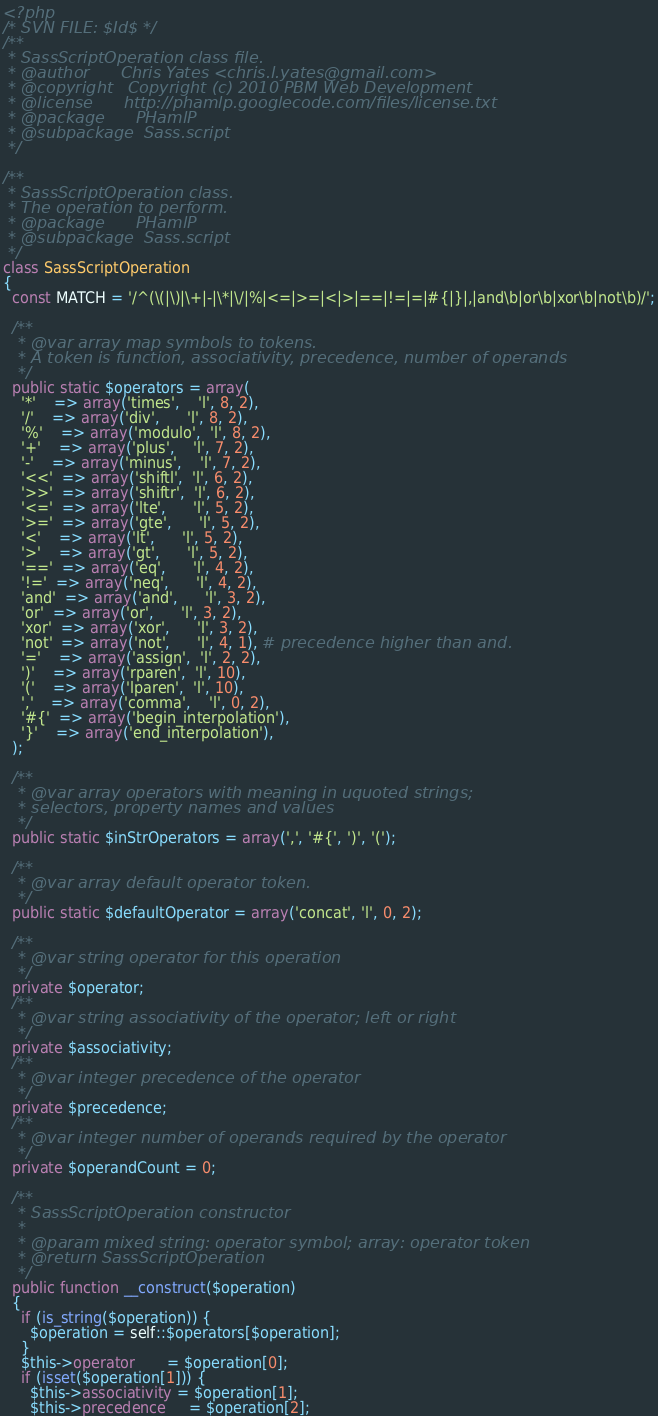Convert code to text. <code><loc_0><loc_0><loc_500><loc_500><_PHP_><?php
/* SVN FILE: $Id$ */
/**
 * SassScriptOperation class file.
 * @author      Chris Yates <chris.l.yates@gmail.com>
 * @copyright   Copyright (c) 2010 PBM Web Development
 * @license      http://phamlp.googlecode.com/files/license.txt
 * @package      PHamlP
 * @subpackage  Sass.script
 */

/**
 * SassScriptOperation class.
 * The operation to perform.
 * @package      PHamlP
 * @subpackage  Sass.script
 */
class SassScriptOperation
{
  const MATCH = '/^(\(|\)|\+|-|\*|\/|%|<=|>=|<|>|==|!=|=|#{|}|,|and\b|or\b|xor\b|not\b)/';

  /**
   * @var array map symbols to tokens.
   * A token is function, associativity, precedence, number of operands
   */
  public static $operators = array(
    '*'    => array('times',    'l', 8, 2),
    '/'    => array('div',      'l', 8, 2),
    '%'    => array('modulo',  'l', 8, 2),
    '+'    => array('plus',    'l', 7, 2),
    '-'    => array('minus',    'l', 7, 2),
    '<<'  => array('shiftl',  'l', 6, 2),
    '>>'  => array('shiftr',  'l', 6, 2),
    '<='  => array('lte',      'l', 5, 2),
    '>='  => array('gte',      'l', 5, 2),
    '<'    => array('lt',      'l', 5, 2),
    '>'    => array('gt',      'l', 5, 2),
    '=='  => array('eq',      'l', 4, 2),
    '!='  => array('neq',      'l', 4, 2),
    'and'  => array('and',      'l', 3, 2),
    'or'  => array('or',      'l', 3, 2),
    'xor'  => array('xor',      'l', 3, 2),
    'not'  => array('not',      'l', 4, 1), # precedence higher than and.
    '='    => array('assign',  'l', 2, 2),
    ')'    => array('rparen',  'l', 10),
    '('    => array('lparen',  'l', 10),
    ','    => array('comma',    'l', 0, 2),
    '#{'  => array('begin_interpolation'),
    '}'    => array('end_interpolation'),
  );

  /**
   * @var array operators with meaning in uquoted strings;
   * selectors, property names and values
   */
  public static $inStrOperators = array(',', '#{', ')', '(');

  /**
   * @var array default operator token.
   */
  public static $defaultOperator = array('concat', 'l', 0, 2);

  /**
   * @var string operator for this operation
   */
  private $operator;
  /**
   * @var string associativity of the operator; left or right
   */
  private $associativity;
  /**
   * @var integer precedence of the operator
   */
  private $precedence;
  /**
   * @var integer number of operands required by the operator
   */
  private $operandCount = 0;

  /**
   * SassScriptOperation constructor
   *
   * @param mixed string: operator symbol; array: operator token
   * @return SassScriptOperation
   */
  public function __construct($operation)
  {
    if (is_string($operation)) {
      $operation = self::$operators[$operation];
    }
    $this->operator       = $operation[0];
    if (isset($operation[1])) {
      $this->associativity = $operation[1];
      $this->precedence     = $operation[2];</code> 